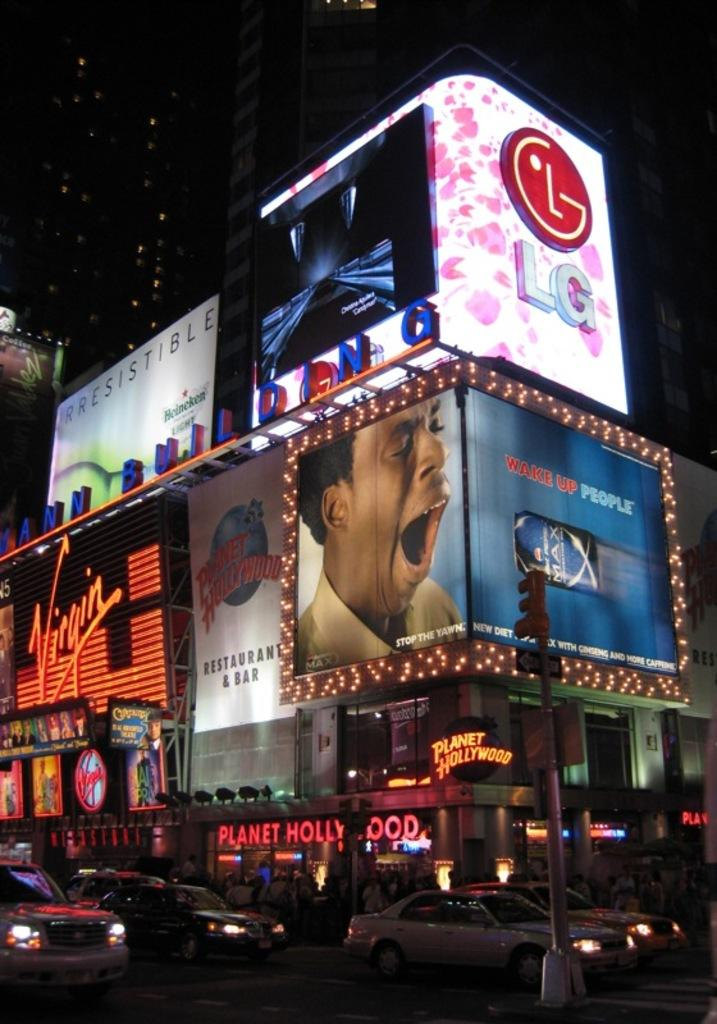Provide a one-sentence caption for the provided image. A Planet Hollywood building is lit up at night with ads for many products. 